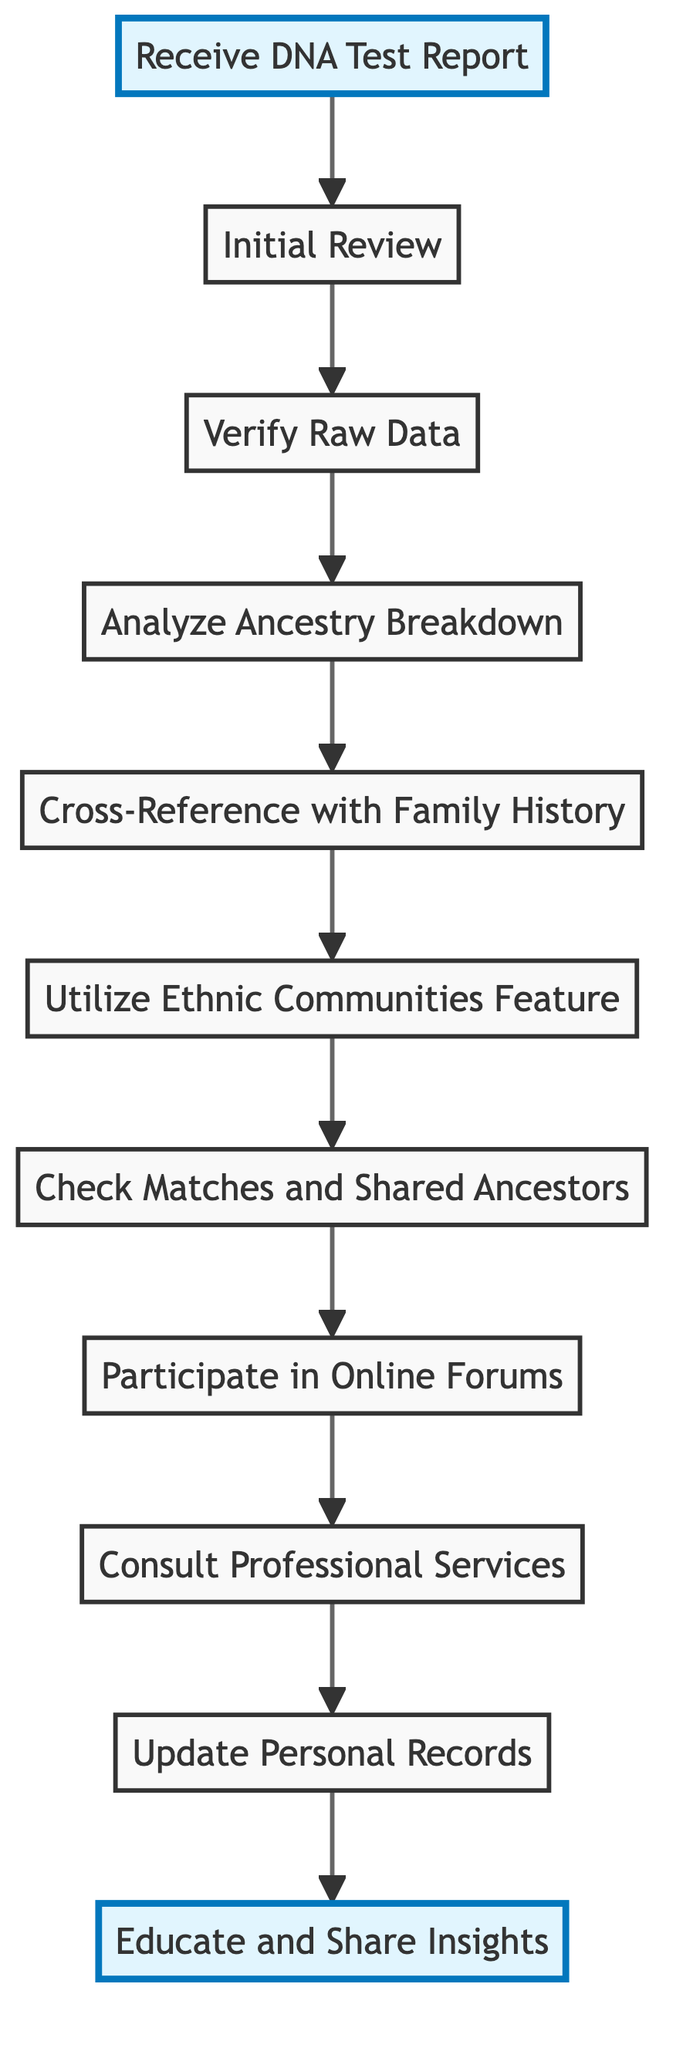What is the first step in the diagram? The first step displayed in the diagram is "Receive DNA Test Report," which appears at the top and is the starting point for the flow.
Answer: Receive DNA Test Report How many total steps are there in the diagram? By counting each node in the flowchart, there are a total of eleven distinct steps leading from the initial report to sharing insights.
Answer: Eleven What step comes after "Analyze Ancestry Breakdown"? The step that directly follows "Analyze Ancestry Breakdown" is "Cross-Reference with Family History," indicating a logical progression in the interpretation process.
Answer: Cross-Reference with Family History What action should you take after checking matches and shared ancestors? After "Check Matches and Shared Ancestors," the next action indicated is "Participate in Online Forums." This shows the suggested continuation in the flow after reviewing genetic connections.
Answer: Participate in Online Forums What is the last step in the flowchart? The last step in the flowchart is "Educate and Share Insights," showing the culmination of the previous steps aimed at sharing knowledge gained from the DNA report.
Answer: Educate and Share Insights Which steps are highlighted in the flowchart? The highlighted steps in the diagram are "Receive DNA Test Report" as the starting point and "Educate and Share Insights" as the concluding action, showing their significance.
Answer: Receive DNA Test Report, Educate and Share Insights What feature should you explore after analyzing ancestry breakdown? Following "Analyze Ancestry Breakdown," the next recommended feature to explore is "Utilize Ethnic Communities Feature," which provides deeper context into the ancestry data.
Answer: Utilize Ethnic Communities Feature Which step involves consulting external expertise? The step that involves seeking external assistance is "Consult Professional Services," indicating a resources-oriented approach for complex interpretations.
Answer: Consult Professional Services 